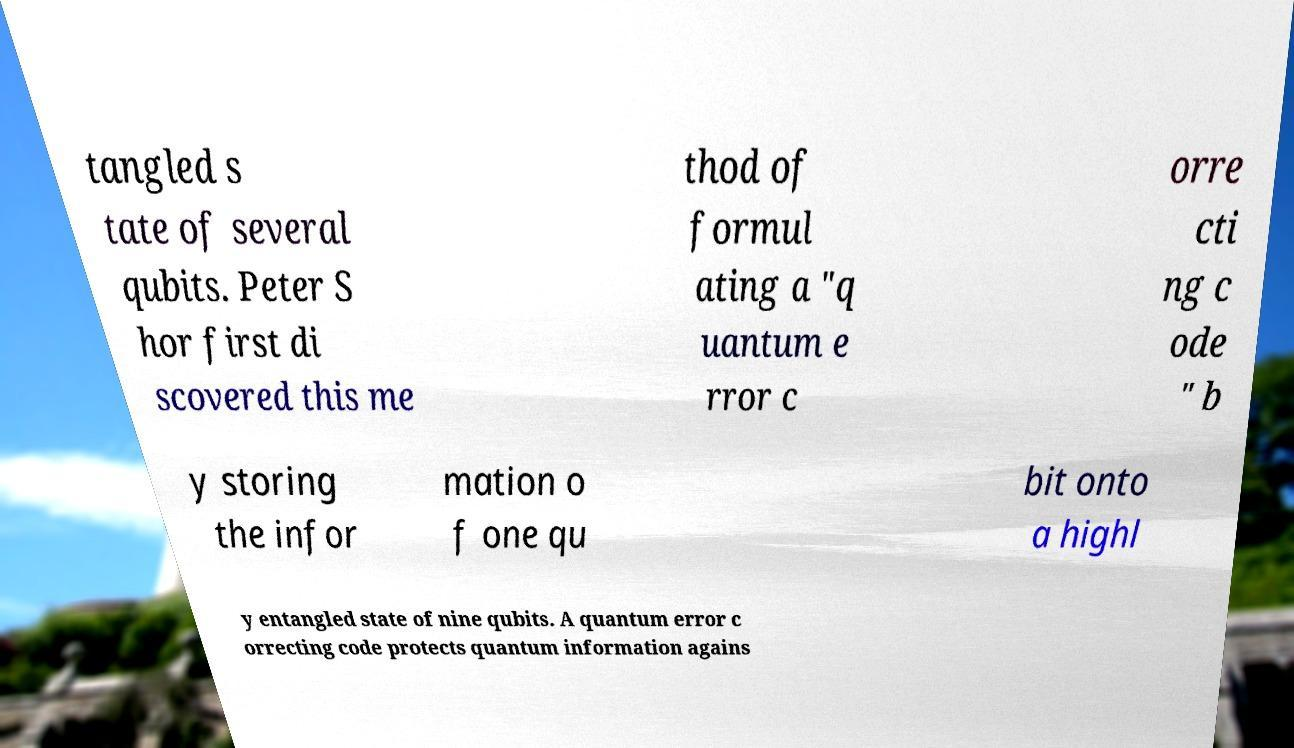Please read and relay the text visible in this image. What does it say? tangled s tate of several qubits. Peter S hor first di scovered this me thod of formul ating a "q uantum e rror c orre cti ng c ode " b y storing the infor mation o f one qu bit onto a highl y entangled state of nine qubits. A quantum error c orrecting code protects quantum information agains 